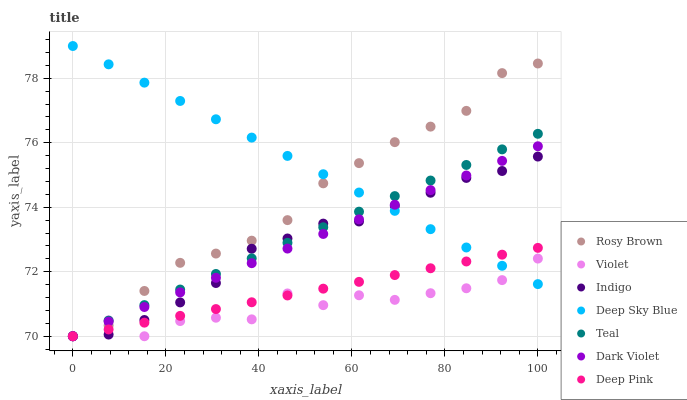Does Violet have the minimum area under the curve?
Answer yes or no. Yes. Does Deep Sky Blue have the maximum area under the curve?
Answer yes or no. Yes. Does Indigo have the minimum area under the curve?
Answer yes or no. No. Does Indigo have the maximum area under the curve?
Answer yes or no. No. Is Teal the smoothest?
Answer yes or no. Yes. Is Violet the roughest?
Answer yes or no. Yes. Is Indigo the smoothest?
Answer yes or no. No. Is Indigo the roughest?
Answer yes or no. No. Does Deep Pink have the lowest value?
Answer yes or no. Yes. Does Deep Sky Blue have the lowest value?
Answer yes or no. No. Does Deep Sky Blue have the highest value?
Answer yes or no. Yes. Does Indigo have the highest value?
Answer yes or no. No. Does Dark Violet intersect Rosy Brown?
Answer yes or no. Yes. Is Dark Violet less than Rosy Brown?
Answer yes or no. No. Is Dark Violet greater than Rosy Brown?
Answer yes or no. No. 